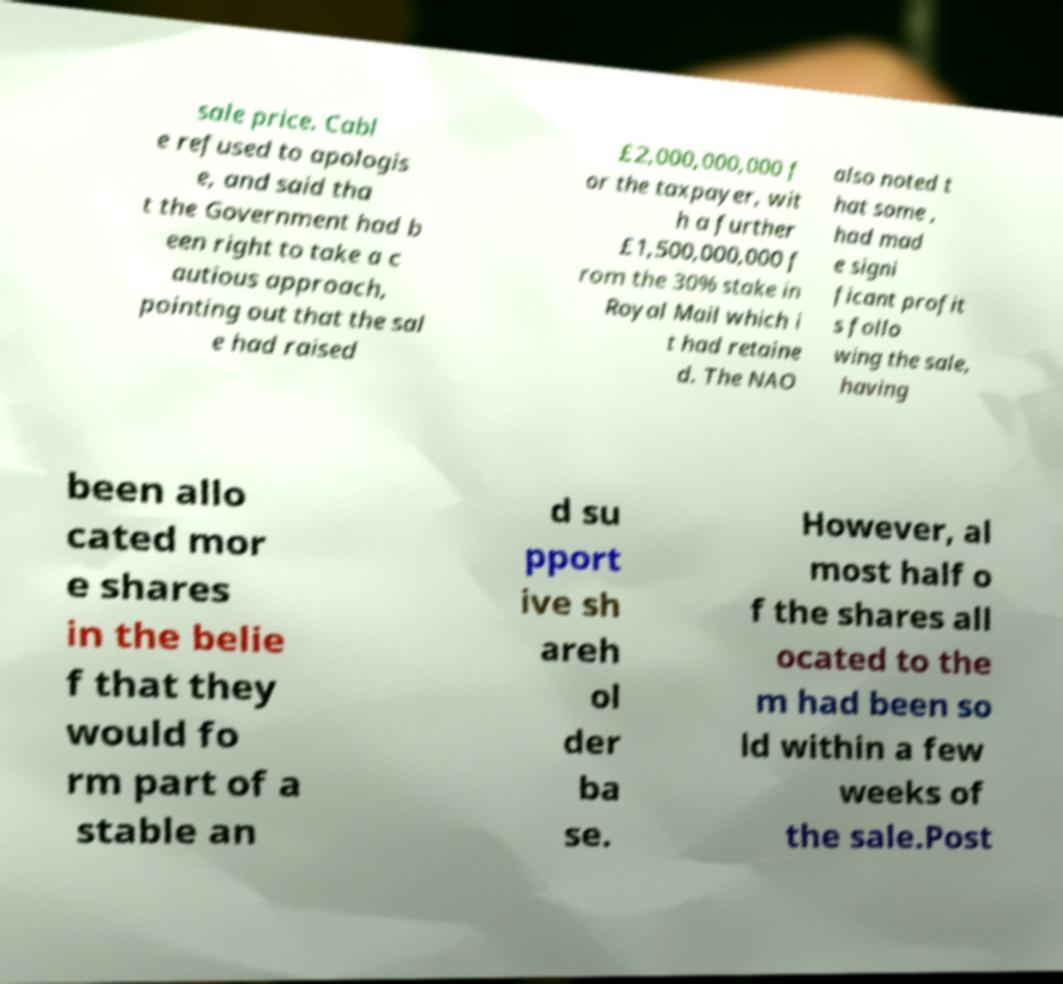What messages or text are displayed in this image? I need them in a readable, typed format. sale price. Cabl e refused to apologis e, and said tha t the Government had b een right to take a c autious approach, pointing out that the sal e had raised £2,000,000,000 f or the taxpayer, wit h a further £1,500,000,000 f rom the 30% stake in Royal Mail which i t had retaine d. The NAO also noted t hat some , had mad e signi ficant profit s follo wing the sale, having been allo cated mor e shares in the belie f that they would fo rm part of a stable an d su pport ive sh areh ol der ba se. However, al most half o f the shares all ocated to the m had been so ld within a few weeks of the sale.Post 